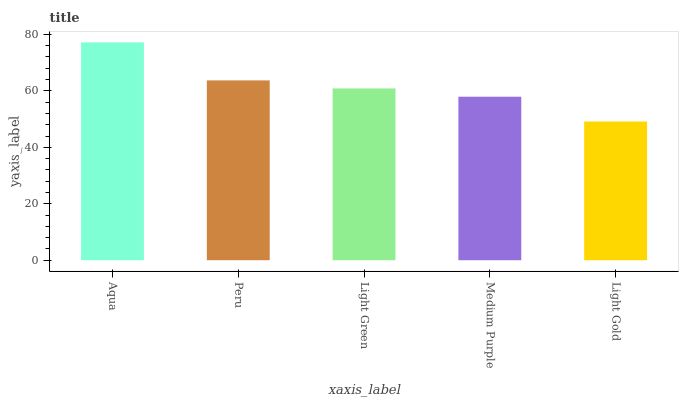Is Light Gold the minimum?
Answer yes or no. Yes. Is Aqua the maximum?
Answer yes or no. Yes. Is Peru the minimum?
Answer yes or no. No. Is Peru the maximum?
Answer yes or no. No. Is Aqua greater than Peru?
Answer yes or no. Yes. Is Peru less than Aqua?
Answer yes or no. Yes. Is Peru greater than Aqua?
Answer yes or no. No. Is Aqua less than Peru?
Answer yes or no. No. Is Light Green the high median?
Answer yes or no. Yes. Is Light Green the low median?
Answer yes or no. Yes. Is Medium Purple the high median?
Answer yes or no. No. Is Medium Purple the low median?
Answer yes or no. No. 